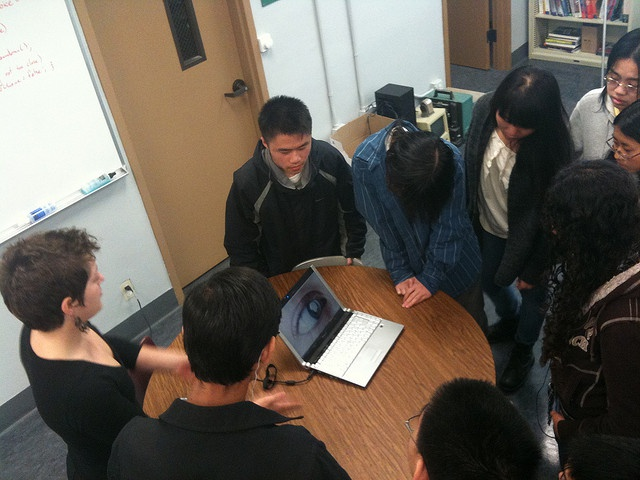Describe the objects in this image and their specific colors. I can see dining table in ivory, gray, brown, and maroon tones, people in ivory, black, gray, darkgray, and maroon tones, people in ivory, black, maroon, and brown tones, people in ivory, black, gray, and maroon tones, and people in ivory, black, and gray tones in this image. 